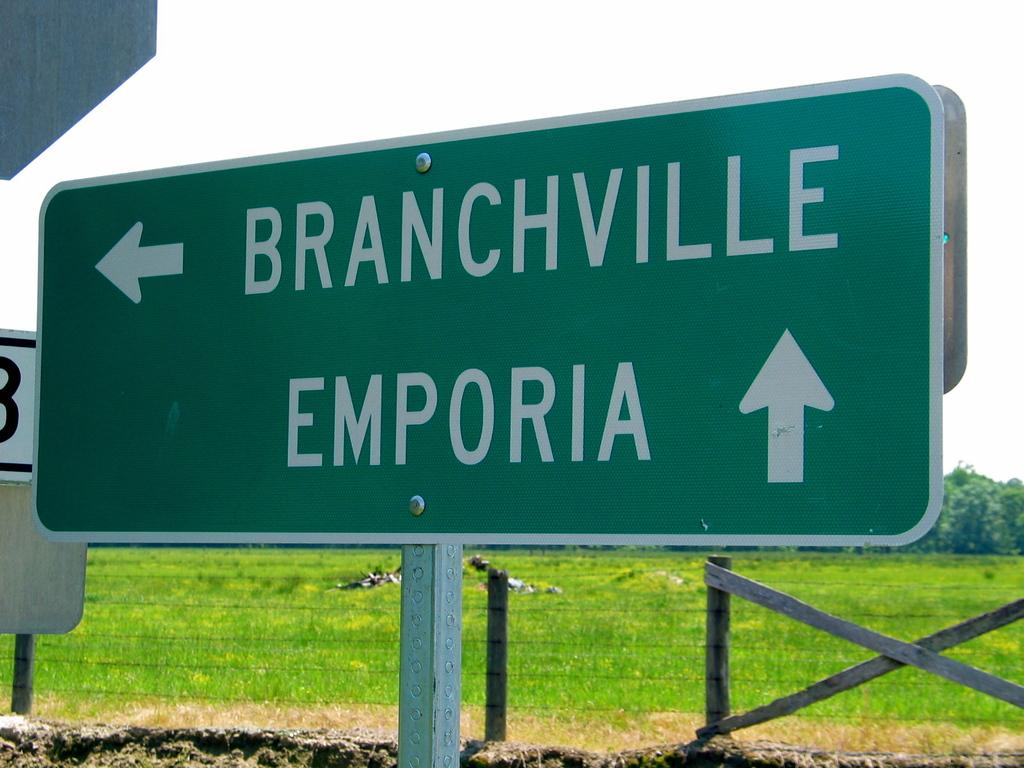<image>
Relay a brief, clear account of the picture shown. the word emporia is on the green sign 